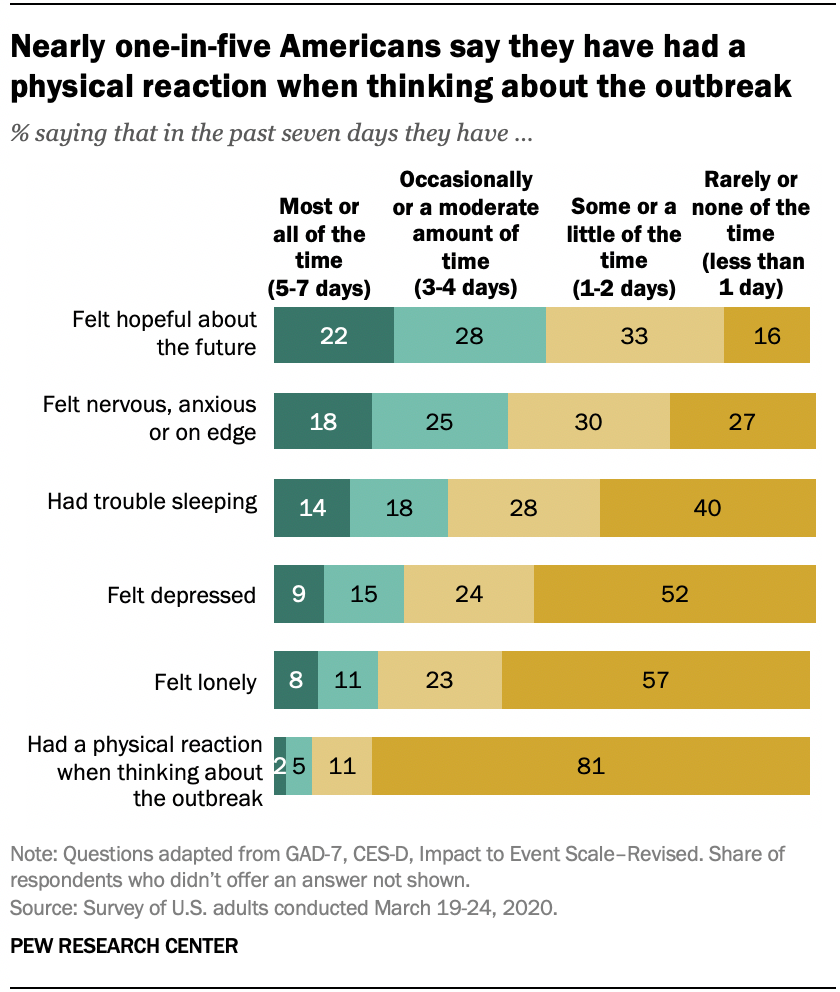Mention a couple of crucial points in this snapshot. According to the survey, 19% of people reported feeling lonely at least occasionally, while 11% reported feeling lonely most or all of the time. According to the survey, a significant percentage of people reported feeling depressed for most or all of the time for five to seven days. 